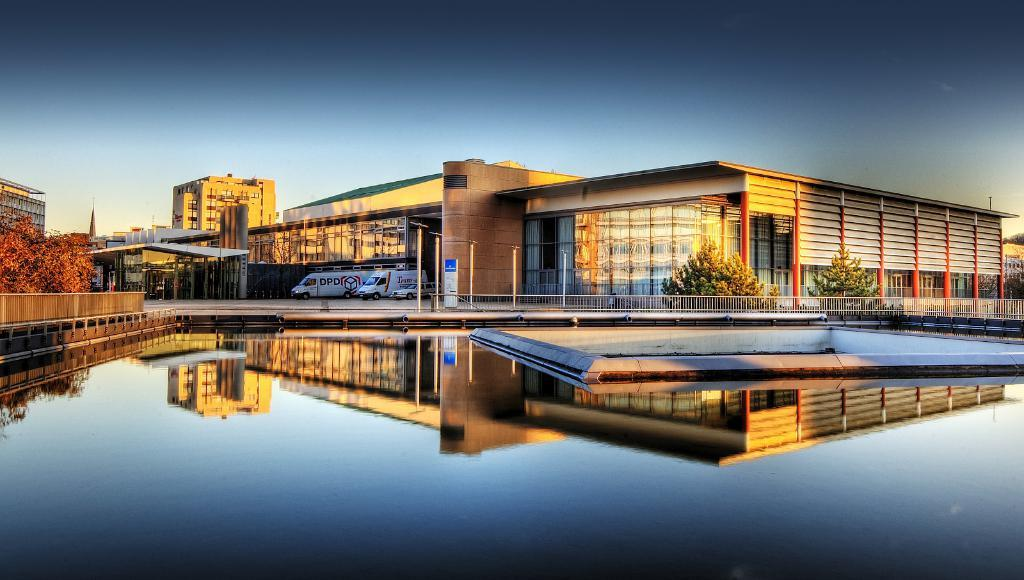What is visible in the image? Water is visible in the image. What type of structure can be seen in the image? There is a fence in the image. What can be seen in the background of the image? There are buildings, trees, vehicles, and poles visible in the background of the image. What part of the natural environment is visible in the image? The sky is visible in the background of the image. What type of wish can be granted by the nest in the image? There is no nest present in the image, so it is not possible to grant any wishes related to a nest. 